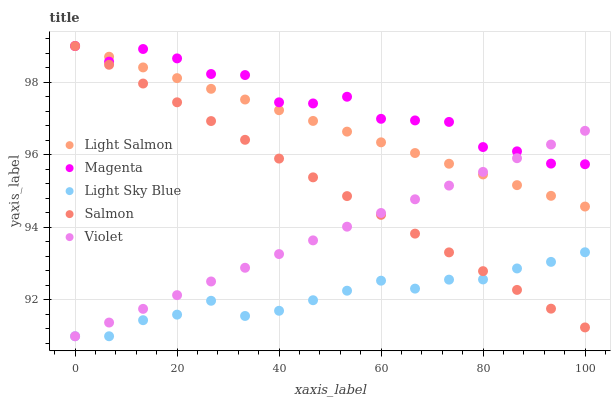Does Light Sky Blue have the minimum area under the curve?
Answer yes or no. Yes. Does Magenta have the maximum area under the curve?
Answer yes or no. Yes. Does Salmon have the minimum area under the curve?
Answer yes or no. No. Does Salmon have the maximum area under the curve?
Answer yes or no. No. Is Light Salmon the smoothest?
Answer yes or no. Yes. Is Magenta the roughest?
Answer yes or no. Yes. Is Light Sky Blue the smoothest?
Answer yes or no. No. Is Light Sky Blue the roughest?
Answer yes or no. No. Does Light Sky Blue have the lowest value?
Answer yes or no. Yes. Does Salmon have the lowest value?
Answer yes or no. No. Does Magenta have the highest value?
Answer yes or no. Yes. Does Light Sky Blue have the highest value?
Answer yes or no. No. Is Light Sky Blue less than Magenta?
Answer yes or no. Yes. Is Light Salmon greater than Light Sky Blue?
Answer yes or no. Yes. Does Violet intersect Light Sky Blue?
Answer yes or no. Yes. Is Violet less than Light Sky Blue?
Answer yes or no. No. Is Violet greater than Light Sky Blue?
Answer yes or no. No. Does Light Sky Blue intersect Magenta?
Answer yes or no. No. 